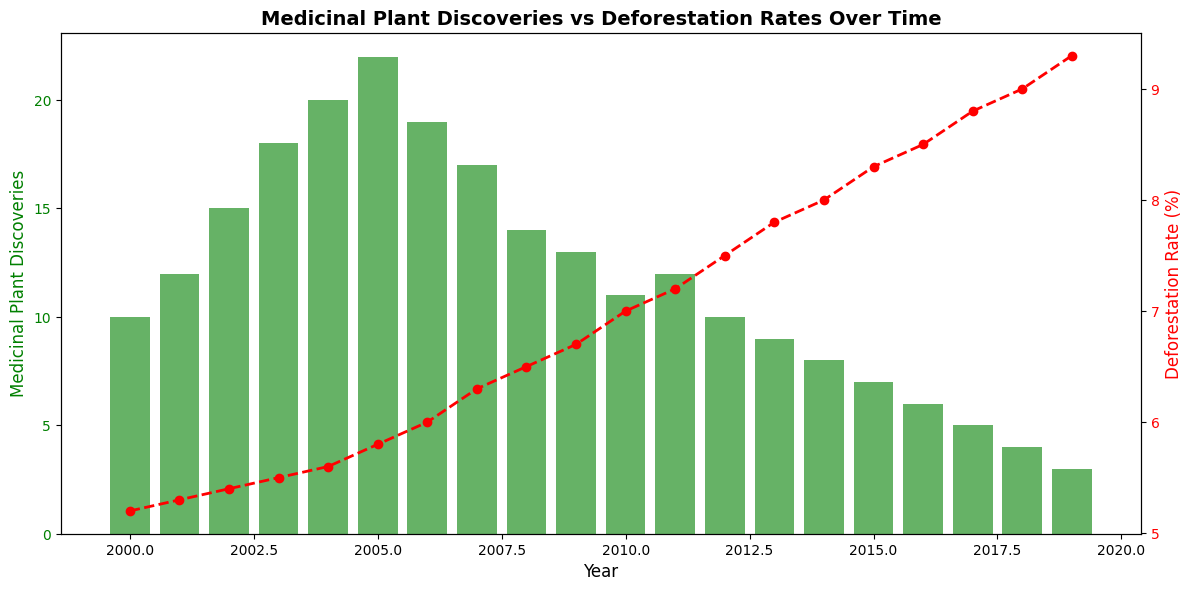How many medicinal plant discoveries were made in 2005, and what was the deforestation rate in the same year? Find the bar height for 2005 which represents medicinal plant discoveries (22) and look at the red line plot for 2005 to find the deforestation rate (5.8%).
Answer: 22, 5.8% What is the general trend in medicinal plant discoveries as deforestation rates increase? Observe the downward trend in the green bars representing medicinal plant discoveries and the upward trend in the red line representing deforestation rates over the years. As deforestation rates increase, medicinal plant discoveries generally decrease.
Answer: Decreasing Which year had the highest number of medicinal plant discoveries and what was the deforestation rate that year? Find the tallest green bar, which is in 2005 with 22 discoveries. The red line plot at 2005 shows the deforestation rate of 5.8%.
Answer: 2005, 5.8% How many more medicinal plant discoveries were there in 2010 compared to 2018? Identify the bar heights for 2010 (11 discoveries) and 2018 (4 discoveries). Subtract 4 from 11 to get the difference.
Answer: 7 What was the deforestation rate in the year when medicinal plant discoveries hit their lowest point and what is that point? Identify the shortest green bar in 2019 with 3 discoveries. The red line plot for 2019 shows the deforestation rate of 9.3%.
Answer: 9.3%, 3 discoveries Compare the number of medicinal plant discoveries in 2002 and 2012. Which year had more discoveries and by how many? Find the bar heights for 2002 (15 discoveries) and 2012 (10 discoveries). Subtract 10 from 15 to find the difference. 2002 had more discoveries.
Answer: 2002, 5 more discoveries What is the average number of medicinal plant discoveries between 2007 and 2011? Find the bar heights for 2007 (17), 2008 (14), 2009 (13), 2010 (11), and 2011 (12). Add these together (17 + 14 + 13 + 11 + 12 = 67) and divide by 5.
Answer: 13.4 Which year saw the highest deforestation rate, and how many medicinal plant discoveries were there in that year? The highest point on the red line is in 2019 with a deforestation rate of 9.3%. The green bar height in 2019 is 3 discoveries.
Answer: 2019, 3 discoveries By how much did the number of medicinal plant discoveries decrease from 2005 to 2019? Find the bar heights for 2005 (22) and 2019 (3). Subtract 3 from 22.
Answer: 19 In what year did the deforestation rate first reach 7% and how many medicinal plant discoveries were made that year? Look at the red line plot to see when it first touches the 7% mark (2010). The green bar height for 2010 shows 11 discoveries.
Answer: 2010, 11 discoveries 